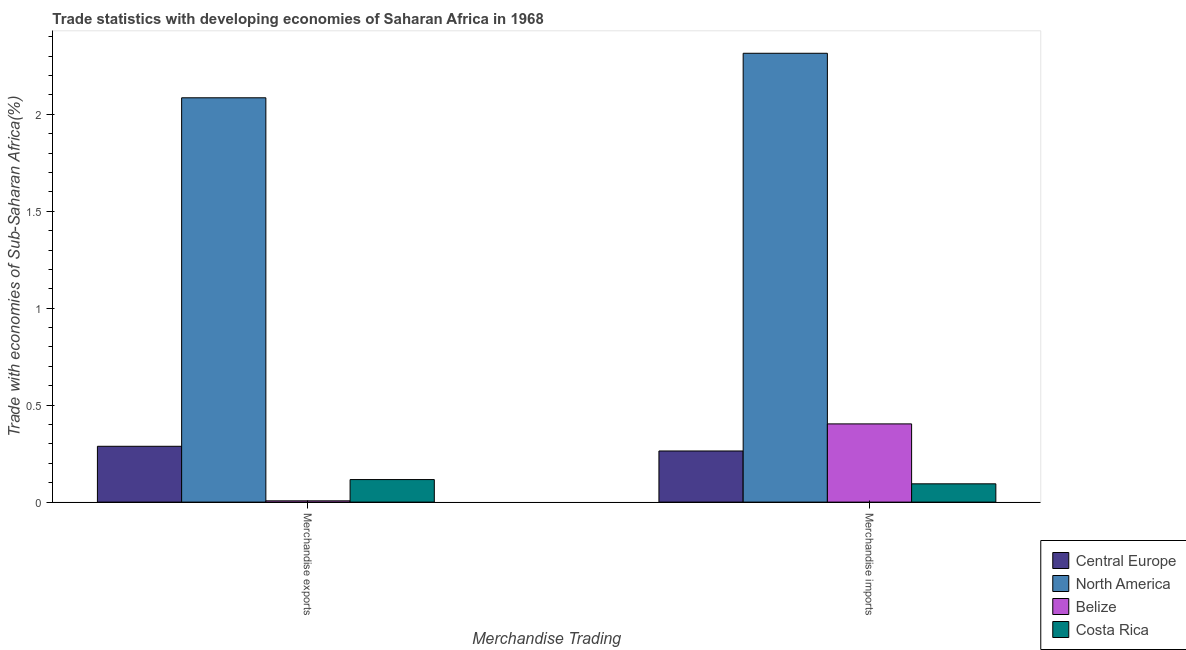How many different coloured bars are there?
Provide a succinct answer. 4. How many bars are there on the 1st tick from the left?
Your answer should be compact. 4. What is the label of the 2nd group of bars from the left?
Give a very brief answer. Merchandise imports. What is the merchandise imports in Central Europe?
Ensure brevity in your answer.  0.26. Across all countries, what is the maximum merchandise imports?
Your response must be concise. 2.31. Across all countries, what is the minimum merchandise imports?
Provide a succinct answer. 0.09. In which country was the merchandise imports maximum?
Give a very brief answer. North America. In which country was the merchandise imports minimum?
Make the answer very short. Costa Rica. What is the total merchandise imports in the graph?
Keep it short and to the point. 3.08. What is the difference between the merchandise exports in Costa Rica and that in Belize?
Provide a succinct answer. 0.11. What is the difference between the merchandise imports in Costa Rica and the merchandise exports in Central Europe?
Ensure brevity in your answer.  -0.19. What is the average merchandise imports per country?
Your answer should be very brief. 0.77. What is the difference between the merchandise exports and merchandise imports in North America?
Your response must be concise. -0.23. What is the ratio of the merchandise exports in Central Europe to that in North America?
Make the answer very short. 0.14. What does the 3rd bar from the right in Merchandise exports represents?
Keep it short and to the point. North America. How many bars are there?
Keep it short and to the point. 8. How many countries are there in the graph?
Your response must be concise. 4. What is the difference between two consecutive major ticks on the Y-axis?
Offer a terse response. 0.5. Does the graph contain grids?
Provide a succinct answer. No. How are the legend labels stacked?
Offer a terse response. Vertical. What is the title of the graph?
Make the answer very short. Trade statistics with developing economies of Saharan Africa in 1968. Does "Hong Kong" appear as one of the legend labels in the graph?
Your answer should be very brief. No. What is the label or title of the X-axis?
Offer a terse response. Merchandise Trading. What is the label or title of the Y-axis?
Ensure brevity in your answer.  Trade with economies of Sub-Saharan Africa(%). What is the Trade with economies of Sub-Saharan Africa(%) in Central Europe in Merchandise exports?
Your answer should be very brief. 0.29. What is the Trade with economies of Sub-Saharan Africa(%) in North America in Merchandise exports?
Offer a terse response. 2.09. What is the Trade with economies of Sub-Saharan Africa(%) in Belize in Merchandise exports?
Your response must be concise. 0.01. What is the Trade with economies of Sub-Saharan Africa(%) of Costa Rica in Merchandise exports?
Keep it short and to the point. 0.12. What is the Trade with economies of Sub-Saharan Africa(%) of Central Europe in Merchandise imports?
Offer a very short reply. 0.26. What is the Trade with economies of Sub-Saharan Africa(%) of North America in Merchandise imports?
Make the answer very short. 2.31. What is the Trade with economies of Sub-Saharan Africa(%) of Belize in Merchandise imports?
Provide a succinct answer. 0.4. What is the Trade with economies of Sub-Saharan Africa(%) of Costa Rica in Merchandise imports?
Offer a terse response. 0.09. Across all Merchandise Trading, what is the maximum Trade with economies of Sub-Saharan Africa(%) in Central Europe?
Ensure brevity in your answer.  0.29. Across all Merchandise Trading, what is the maximum Trade with economies of Sub-Saharan Africa(%) of North America?
Provide a short and direct response. 2.31. Across all Merchandise Trading, what is the maximum Trade with economies of Sub-Saharan Africa(%) in Belize?
Your answer should be compact. 0.4. Across all Merchandise Trading, what is the maximum Trade with economies of Sub-Saharan Africa(%) of Costa Rica?
Your answer should be very brief. 0.12. Across all Merchandise Trading, what is the minimum Trade with economies of Sub-Saharan Africa(%) of Central Europe?
Give a very brief answer. 0.26. Across all Merchandise Trading, what is the minimum Trade with economies of Sub-Saharan Africa(%) in North America?
Offer a very short reply. 2.09. Across all Merchandise Trading, what is the minimum Trade with economies of Sub-Saharan Africa(%) in Belize?
Provide a short and direct response. 0.01. Across all Merchandise Trading, what is the minimum Trade with economies of Sub-Saharan Africa(%) in Costa Rica?
Offer a very short reply. 0.09. What is the total Trade with economies of Sub-Saharan Africa(%) in Central Europe in the graph?
Your answer should be compact. 0.55. What is the total Trade with economies of Sub-Saharan Africa(%) of North America in the graph?
Give a very brief answer. 4.4. What is the total Trade with economies of Sub-Saharan Africa(%) in Belize in the graph?
Keep it short and to the point. 0.41. What is the total Trade with economies of Sub-Saharan Africa(%) of Costa Rica in the graph?
Give a very brief answer. 0.21. What is the difference between the Trade with economies of Sub-Saharan Africa(%) of Central Europe in Merchandise exports and that in Merchandise imports?
Your answer should be compact. 0.02. What is the difference between the Trade with economies of Sub-Saharan Africa(%) in North America in Merchandise exports and that in Merchandise imports?
Offer a terse response. -0.23. What is the difference between the Trade with economies of Sub-Saharan Africa(%) in Belize in Merchandise exports and that in Merchandise imports?
Your answer should be compact. -0.4. What is the difference between the Trade with economies of Sub-Saharan Africa(%) in Costa Rica in Merchandise exports and that in Merchandise imports?
Provide a short and direct response. 0.02. What is the difference between the Trade with economies of Sub-Saharan Africa(%) of Central Europe in Merchandise exports and the Trade with economies of Sub-Saharan Africa(%) of North America in Merchandise imports?
Provide a succinct answer. -2.03. What is the difference between the Trade with economies of Sub-Saharan Africa(%) of Central Europe in Merchandise exports and the Trade with economies of Sub-Saharan Africa(%) of Belize in Merchandise imports?
Give a very brief answer. -0.12. What is the difference between the Trade with economies of Sub-Saharan Africa(%) of Central Europe in Merchandise exports and the Trade with economies of Sub-Saharan Africa(%) of Costa Rica in Merchandise imports?
Ensure brevity in your answer.  0.19. What is the difference between the Trade with economies of Sub-Saharan Africa(%) in North America in Merchandise exports and the Trade with economies of Sub-Saharan Africa(%) in Belize in Merchandise imports?
Offer a terse response. 1.68. What is the difference between the Trade with economies of Sub-Saharan Africa(%) of North America in Merchandise exports and the Trade with economies of Sub-Saharan Africa(%) of Costa Rica in Merchandise imports?
Give a very brief answer. 1.99. What is the difference between the Trade with economies of Sub-Saharan Africa(%) of Belize in Merchandise exports and the Trade with economies of Sub-Saharan Africa(%) of Costa Rica in Merchandise imports?
Your answer should be very brief. -0.09. What is the average Trade with economies of Sub-Saharan Africa(%) of Central Europe per Merchandise Trading?
Offer a terse response. 0.28. What is the average Trade with economies of Sub-Saharan Africa(%) in Belize per Merchandise Trading?
Your answer should be very brief. 0.2. What is the average Trade with economies of Sub-Saharan Africa(%) in Costa Rica per Merchandise Trading?
Your answer should be very brief. 0.11. What is the difference between the Trade with economies of Sub-Saharan Africa(%) in Central Europe and Trade with economies of Sub-Saharan Africa(%) in North America in Merchandise exports?
Make the answer very short. -1.8. What is the difference between the Trade with economies of Sub-Saharan Africa(%) in Central Europe and Trade with economies of Sub-Saharan Africa(%) in Belize in Merchandise exports?
Your answer should be compact. 0.28. What is the difference between the Trade with economies of Sub-Saharan Africa(%) of Central Europe and Trade with economies of Sub-Saharan Africa(%) of Costa Rica in Merchandise exports?
Keep it short and to the point. 0.17. What is the difference between the Trade with economies of Sub-Saharan Africa(%) of North America and Trade with economies of Sub-Saharan Africa(%) of Belize in Merchandise exports?
Your answer should be very brief. 2.08. What is the difference between the Trade with economies of Sub-Saharan Africa(%) in North America and Trade with economies of Sub-Saharan Africa(%) in Costa Rica in Merchandise exports?
Keep it short and to the point. 1.97. What is the difference between the Trade with economies of Sub-Saharan Africa(%) in Belize and Trade with economies of Sub-Saharan Africa(%) in Costa Rica in Merchandise exports?
Ensure brevity in your answer.  -0.11. What is the difference between the Trade with economies of Sub-Saharan Africa(%) in Central Europe and Trade with economies of Sub-Saharan Africa(%) in North America in Merchandise imports?
Ensure brevity in your answer.  -2.05. What is the difference between the Trade with economies of Sub-Saharan Africa(%) of Central Europe and Trade with economies of Sub-Saharan Africa(%) of Belize in Merchandise imports?
Offer a very short reply. -0.14. What is the difference between the Trade with economies of Sub-Saharan Africa(%) in Central Europe and Trade with economies of Sub-Saharan Africa(%) in Costa Rica in Merchandise imports?
Offer a very short reply. 0.17. What is the difference between the Trade with economies of Sub-Saharan Africa(%) in North America and Trade with economies of Sub-Saharan Africa(%) in Belize in Merchandise imports?
Offer a very short reply. 1.91. What is the difference between the Trade with economies of Sub-Saharan Africa(%) in North America and Trade with economies of Sub-Saharan Africa(%) in Costa Rica in Merchandise imports?
Your response must be concise. 2.22. What is the difference between the Trade with economies of Sub-Saharan Africa(%) of Belize and Trade with economies of Sub-Saharan Africa(%) of Costa Rica in Merchandise imports?
Ensure brevity in your answer.  0.31. What is the ratio of the Trade with economies of Sub-Saharan Africa(%) in Central Europe in Merchandise exports to that in Merchandise imports?
Give a very brief answer. 1.09. What is the ratio of the Trade with economies of Sub-Saharan Africa(%) of North America in Merchandise exports to that in Merchandise imports?
Make the answer very short. 0.9. What is the ratio of the Trade with economies of Sub-Saharan Africa(%) of Belize in Merchandise exports to that in Merchandise imports?
Make the answer very short. 0.02. What is the ratio of the Trade with economies of Sub-Saharan Africa(%) of Costa Rica in Merchandise exports to that in Merchandise imports?
Offer a very short reply. 1.23. What is the difference between the highest and the second highest Trade with economies of Sub-Saharan Africa(%) of Central Europe?
Provide a short and direct response. 0.02. What is the difference between the highest and the second highest Trade with economies of Sub-Saharan Africa(%) in North America?
Your answer should be very brief. 0.23. What is the difference between the highest and the second highest Trade with economies of Sub-Saharan Africa(%) in Belize?
Provide a short and direct response. 0.4. What is the difference between the highest and the second highest Trade with economies of Sub-Saharan Africa(%) in Costa Rica?
Ensure brevity in your answer.  0.02. What is the difference between the highest and the lowest Trade with economies of Sub-Saharan Africa(%) of Central Europe?
Offer a very short reply. 0.02. What is the difference between the highest and the lowest Trade with economies of Sub-Saharan Africa(%) in North America?
Ensure brevity in your answer.  0.23. What is the difference between the highest and the lowest Trade with economies of Sub-Saharan Africa(%) in Belize?
Your answer should be compact. 0.4. What is the difference between the highest and the lowest Trade with economies of Sub-Saharan Africa(%) in Costa Rica?
Give a very brief answer. 0.02. 